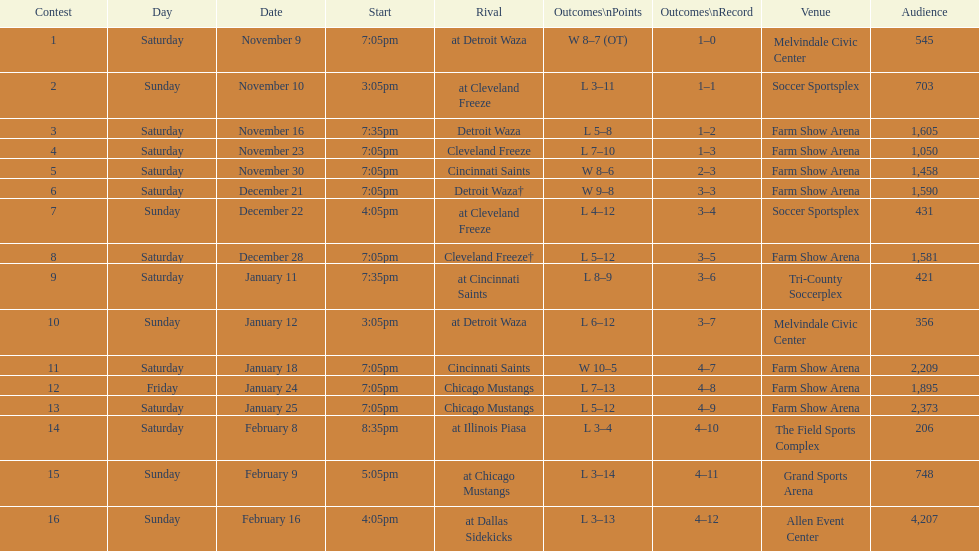How long was the teams longest losing streak? 5 games. 